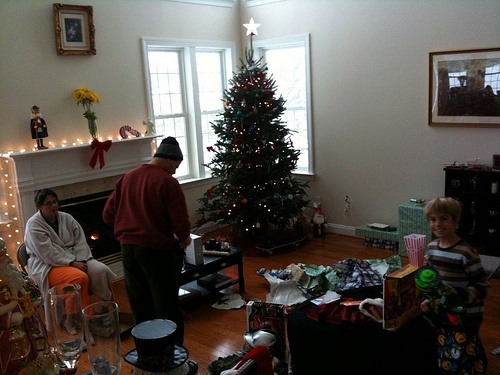Describe the objects in this image and their specific colors. I can see people in gray, black, and maroon tones, people in gray, black, and maroon tones, people in gray, black, and maroon tones, wine glass in gray, black, and maroon tones, and chair in gray, black, maroon, and darkblue tones in this image. 